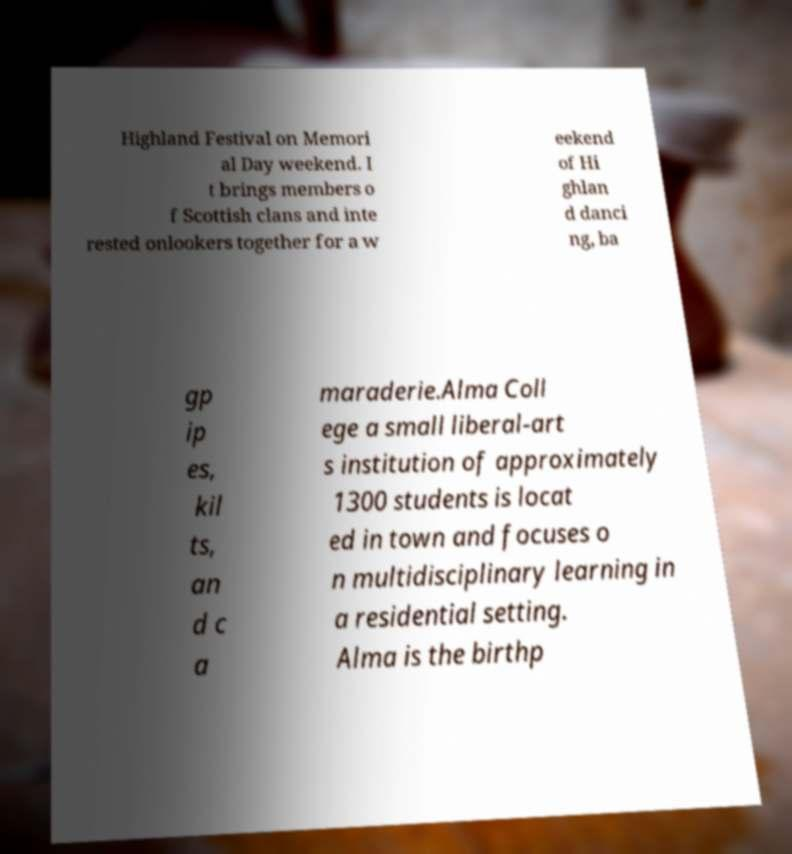What messages or text are displayed in this image? I need them in a readable, typed format. Highland Festival on Memori al Day weekend. I t brings members o f Scottish clans and inte rested onlookers together for a w eekend of Hi ghlan d danci ng, ba gp ip es, kil ts, an d c a maraderie.Alma Coll ege a small liberal-art s institution of approximately 1300 students is locat ed in town and focuses o n multidisciplinary learning in a residential setting. Alma is the birthp 